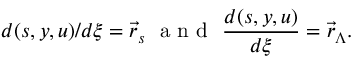<formula> <loc_0><loc_0><loc_500><loc_500>d ( s , y , u ) / d \xi = \vec { r } _ { s } a n d \frac { d ( s , y , u ) } { d \xi } = \vec { r } _ { \Lambda } .</formula> 